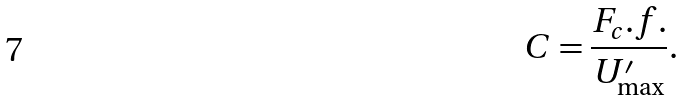<formula> <loc_0><loc_0><loc_500><loc_500>C = \frac { F _ { c } . f . } { U ^ { \prime } _ { \max } } .</formula> 